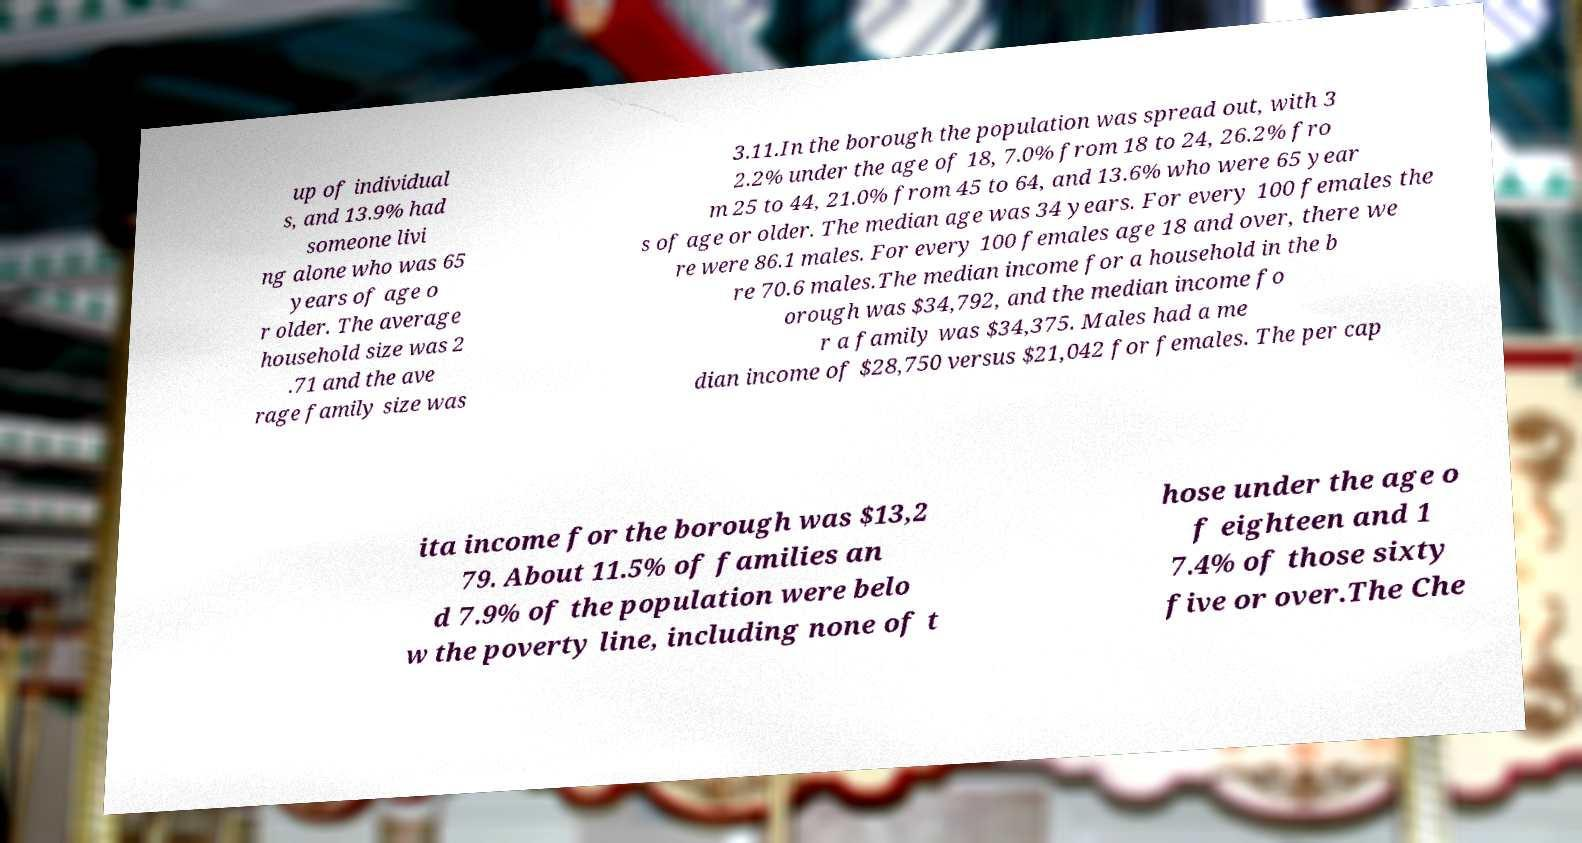What messages or text are displayed in this image? I need them in a readable, typed format. up of individual s, and 13.9% had someone livi ng alone who was 65 years of age o r older. The average household size was 2 .71 and the ave rage family size was 3.11.In the borough the population was spread out, with 3 2.2% under the age of 18, 7.0% from 18 to 24, 26.2% fro m 25 to 44, 21.0% from 45 to 64, and 13.6% who were 65 year s of age or older. The median age was 34 years. For every 100 females the re were 86.1 males. For every 100 females age 18 and over, there we re 70.6 males.The median income for a household in the b orough was $34,792, and the median income fo r a family was $34,375. Males had a me dian income of $28,750 versus $21,042 for females. The per cap ita income for the borough was $13,2 79. About 11.5% of families an d 7.9% of the population were belo w the poverty line, including none of t hose under the age o f eighteen and 1 7.4% of those sixty five or over.The Che 